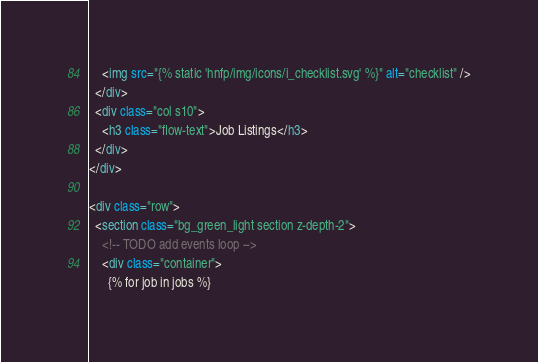Convert code to text. <code><loc_0><loc_0><loc_500><loc_500><_HTML_>    <img src="{% static 'hnfp/img/icons/i_checklist.svg' %}" alt="checklist" />
  </div>
  <div class="col s10">
    <h3 class="flow-text">Job Listings</h3>
  </div>
</div>

<div class="row">
  <section class="bg_green_light section z-depth-2">
    <!-- TODO add events loop -->
    <div class="container">
      {% for job in jobs %}</code> 